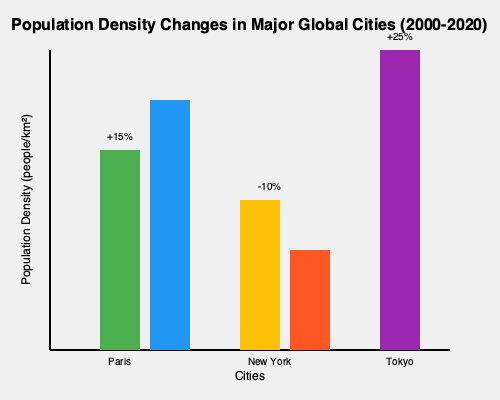Based on the graph showing population density changes in major global cities from 2000 to 2020, which city experienced the most significant percentage increase in population density, and how might this trend relate to the socio-economic effects of globalization? To answer this question, we need to analyze the graph and interpret the data in the context of globalization:

1. Identify the cities and their changes:
   - Paris: Increased by 15%
   - New York: Decreased by 10%
   - Tokyo: Increased by 25%

2. Determine the city with the most significant percentage increase:
   Tokyo shows the highest percentage increase at 25%.

3. Relate this trend to socio-economic effects of globalization:
   a) Urbanization: The significant increase in Tokyo's population density reflects the global trend of urbanization, often accelerated by globalization.
   b) Economic opportunities: As a global financial hub, Tokyo attracts international businesses and workers, contributing to population growth.
   c) Technology and innovation: Tokyo's status as a tech center draws skilled workers from around the world.
   d) Cultural exchange: Increased diversity due to international migration, a key aspect of globalization.
   e) Infrastructure challenges: Rapid population growth can strain urban infrastructure, requiring innovative solutions.
   f) Income inequality: High-density urban areas often experience widening gaps between socio-economic classes.
   g) Environmental impact: Increased population density can lead to higher pollution levels and resource consumption.

4. Contrast with other cities:
   - Paris shows moderate growth, possibly due to similar globalization factors but on a smaller scale.
   - New York's decrease could indicate shifting global economic patterns or local policies affecting population distribution.

The significant increase in Tokyo's population density illustrates how globalization can concentrate people in major economic centers, bringing both opportunities and challenges to urban environments.
Answer: Tokyo (25% increase); reflects urbanization, economic opportunities, and challenges associated with globalization in major cities. 